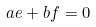<formula> <loc_0><loc_0><loc_500><loc_500>a e + b f = 0</formula> 